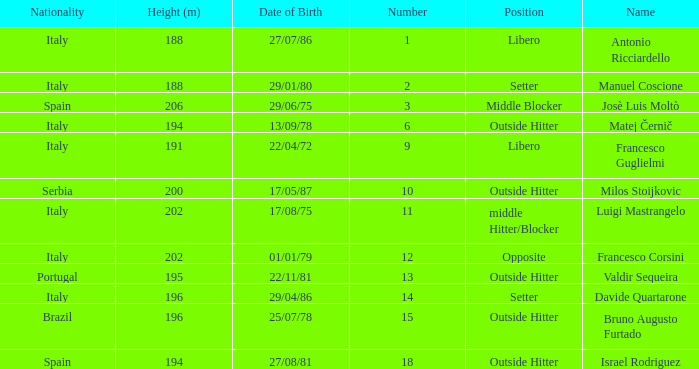Name the least number 1.0. 